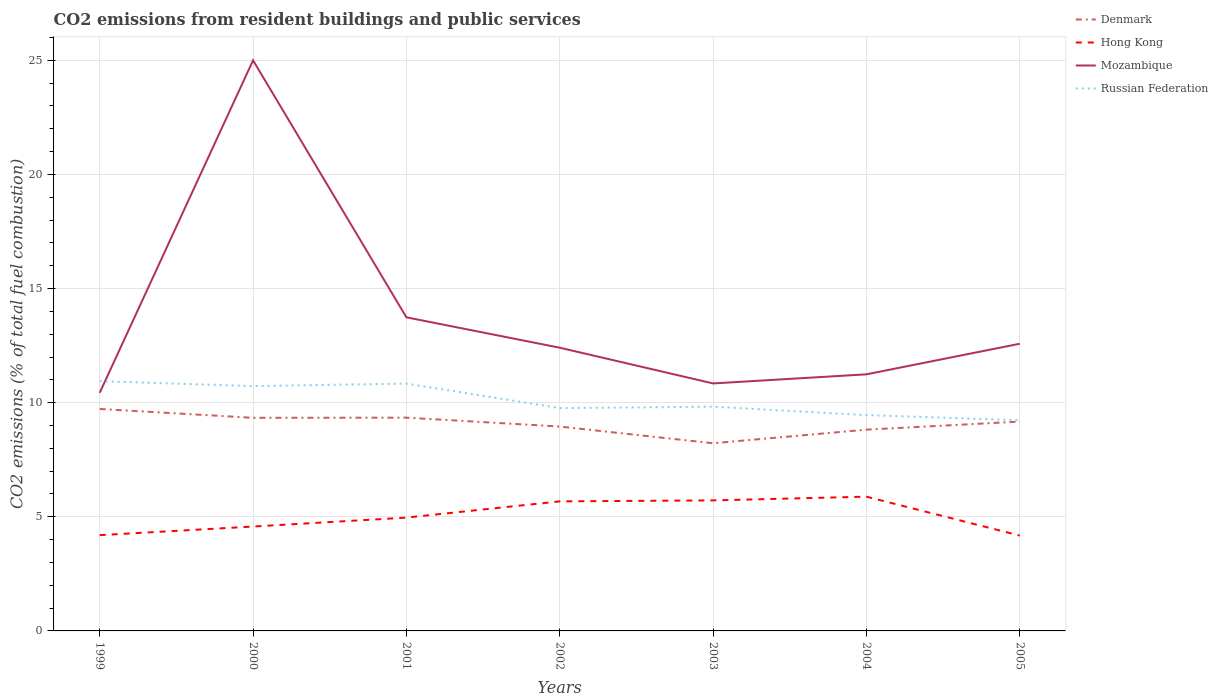How many different coloured lines are there?
Give a very brief answer. 4. Does the line corresponding to Hong Kong intersect with the line corresponding to Russian Federation?
Offer a terse response. No. Across all years, what is the maximum total CO2 emitted in Hong Kong?
Ensure brevity in your answer.  4.18. What is the total total CO2 emitted in Hong Kong in the graph?
Offer a very short reply. 0.02. What is the difference between the highest and the second highest total CO2 emitted in Mozambique?
Offer a very short reply. 14.57. How many lines are there?
Make the answer very short. 4. What is the difference between two consecutive major ticks on the Y-axis?
Ensure brevity in your answer.  5. Are the values on the major ticks of Y-axis written in scientific E-notation?
Your answer should be very brief. No. Does the graph contain any zero values?
Offer a terse response. No. Does the graph contain grids?
Your response must be concise. Yes. How are the legend labels stacked?
Make the answer very short. Vertical. What is the title of the graph?
Your answer should be compact. CO2 emissions from resident buildings and public services. Does "South Asia" appear as one of the legend labels in the graph?
Make the answer very short. No. What is the label or title of the Y-axis?
Ensure brevity in your answer.  CO2 emissions (% of total fuel combustion). What is the CO2 emissions (% of total fuel combustion) of Denmark in 1999?
Ensure brevity in your answer.  9.72. What is the CO2 emissions (% of total fuel combustion) of Hong Kong in 1999?
Your answer should be compact. 4.2. What is the CO2 emissions (% of total fuel combustion) in Mozambique in 1999?
Your answer should be compact. 10.43. What is the CO2 emissions (% of total fuel combustion) of Russian Federation in 1999?
Your response must be concise. 10.94. What is the CO2 emissions (% of total fuel combustion) in Denmark in 2000?
Your answer should be very brief. 9.34. What is the CO2 emissions (% of total fuel combustion) of Hong Kong in 2000?
Provide a succinct answer. 4.57. What is the CO2 emissions (% of total fuel combustion) of Russian Federation in 2000?
Provide a short and direct response. 10.73. What is the CO2 emissions (% of total fuel combustion) of Denmark in 2001?
Make the answer very short. 9.34. What is the CO2 emissions (% of total fuel combustion) of Hong Kong in 2001?
Offer a terse response. 4.96. What is the CO2 emissions (% of total fuel combustion) of Mozambique in 2001?
Provide a succinct answer. 13.74. What is the CO2 emissions (% of total fuel combustion) in Russian Federation in 2001?
Offer a terse response. 10.84. What is the CO2 emissions (% of total fuel combustion) of Denmark in 2002?
Offer a very short reply. 8.95. What is the CO2 emissions (% of total fuel combustion) in Hong Kong in 2002?
Your response must be concise. 5.68. What is the CO2 emissions (% of total fuel combustion) of Mozambique in 2002?
Provide a short and direct response. 12.41. What is the CO2 emissions (% of total fuel combustion) of Russian Federation in 2002?
Provide a short and direct response. 9.76. What is the CO2 emissions (% of total fuel combustion) in Denmark in 2003?
Keep it short and to the point. 8.22. What is the CO2 emissions (% of total fuel combustion) in Hong Kong in 2003?
Provide a succinct answer. 5.72. What is the CO2 emissions (% of total fuel combustion) of Mozambique in 2003?
Provide a succinct answer. 10.84. What is the CO2 emissions (% of total fuel combustion) of Russian Federation in 2003?
Your answer should be very brief. 9.83. What is the CO2 emissions (% of total fuel combustion) in Denmark in 2004?
Make the answer very short. 8.82. What is the CO2 emissions (% of total fuel combustion) of Hong Kong in 2004?
Offer a terse response. 5.88. What is the CO2 emissions (% of total fuel combustion) in Mozambique in 2004?
Offer a very short reply. 11.24. What is the CO2 emissions (% of total fuel combustion) in Russian Federation in 2004?
Keep it short and to the point. 9.46. What is the CO2 emissions (% of total fuel combustion) of Denmark in 2005?
Give a very brief answer. 9.17. What is the CO2 emissions (% of total fuel combustion) in Hong Kong in 2005?
Offer a very short reply. 4.18. What is the CO2 emissions (% of total fuel combustion) of Mozambique in 2005?
Give a very brief answer. 12.58. What is the CO2 emissions (% of total fuel combustion) in Russian Federation in 2005?
Provide a succinct answer. 9.23. Across all years, what is the maximum CO2 emissions (% of total fuel combustion) of Denmark?
Ensure brevity in your answer.  9.72. Across all years, what is the maximum CO2 emissions (% of total fuel combustion) of Hong Kong?
Provide a succinct answer. 5.88. Across all years, what is the maximum CO2 emissions (% of total fuel combustion) of Mozambique?
Offer a terse response. 25. Across all years, what is the maximum CO2 emissions (% of total fuel combustion) in Russian Federation?
Provide a short and direct response. 10.94. Across all years, what is the minimum CO2 emissions (% of total fuel combustion) in Denmark?
Offer a terse response. 8.22. Across all years, what is the minimum CO2 emissions (% of total fuel combustion) of Hong Kong?
Ensure brevity in your answer.  4.18. Across all years, what is the minimum CO2 emissions (% of total fuel combustion) of Mozambique?
Offer a very short reply. 10.43. Across all years, what is the minimum CO2 emissions (% of total fuel combustion) of Russian Federation?
Offer a terse response. 9.23. What is the total CO2 emissions (% of total fuel combustion) of Denmark in the graph?
Your answer should be very brief. 63.57. What is the total CO2 emissions (% of total fuel combustion) of Hong Kong in the graph?
Your response must be concise. 35.19. What is the total CO2 emissions (% of total fuel combustion) in Mozambique in the graph?
Provide a succinct answer. 96.25. What is the total CO2 emissions (% of total fuel combustion) of Russian Federation in the graph?
Keep it short and to the point. 70.78. What is the difference between the CO2 emissions (% of total fuel combustion) of Denmark in 1999 and that in 2000?
Make the answer very short. 0.39. What is the difference between the CO2 emissions (% of total fuel combustion) of Hong Kong in 1999 and that in 2000?
Your answer should be compact. -0.38. What is the difference between the CO2 emissions (% of total fuel combustion) in Mozambique in 1999 and that in 2000?
Ensure brevity in your answer.  -14.57. What is the difference between the CO2 emissions (% of total fuel combustion) of Russian Federation in 1999 and that in 2000?
Provide a short and direct response. 0.21. What is the difference between the CO2 emissions (% of total fuel combustion) in Denmark in 1999 and that in 2001?
Your answer should be compact. 0.38. What is the difference between the CO2 emissions (% of total fuel combustion) in Hong Kong in 1999 and that in 2001?
Offer a terse response. -0.77. What is the difference between the CO2 emissions (% of total fuel combustion) in Mozambique in 1999 and that in 2001?
Your answer should be very brief. -3.31. What is the difference between the CO2 emissions (% of total fuel combustion) of Russian Federation in 1999 and that in 2001?
Give a very brief answer. 0.11. What is the difference between the CO2 emissions (% of total fuel combustion) in Denmark in 1999 and that in 2002?
Give a very brief answer. 0.77. What is the difference between the CO2 emissions (% of total fuel combustion) in Hong Kong in 1999 and that in 2002?
Give a very brief answer. -1.48. What is the difference between the CO2 emissions (% of total fuel combustion) of Mozambique in 1999 and that in 2002?
Give a very brief answer. -1.97. What is the difference between the CO2 emissions (% of total fuel combustion) in Russian Federation in 1999 and that in 2002?
Provide a short and direct response. 1.18. What is the difference between the CO2 emissions (% of total fuel combustion) of Denmark in 1999 and that in 2003?
Your response must be concise. 1.5. What is the difference between the CO2 emissions (% of total fuel combustion) of Hong Kong in 1999 and that in 2003?
Keep it short and to the point. -1.52. What is the difference between the CO2 emissions (% of total fuel combustion) of Mozambique in 1999 and that in 2003?
Offer a very short reply. -0.41. What is the difference between the CO2 emissions (% of total fuel combustion) of Russian Federation in 1999 and that in 2003?
Your response must be concise. 1.12. What is the difference between the CO2 emissions (% of total fuel combustion) in Denmark in 1999 and that in 2004?
Offer a very short reply. 0.91. What is the difference between the CO2 emissions (% of total fuel combustion) of Hong Kong in 1999 and that in 2004?
Provide a succinct answer. -1.69. What is the difference between the CO2 emissions (% of total fuel combustion) in Mozambique in 1999 and that in 2004?
Offer a very short reply. -0.81. What is the difference between the CO2 emissions (% of total fuel combustion) of Russian Federation in 1999 and that in 2004?
Give a very brief answer. 1.49. What is the difference between the CO2 emissions (% of total fuel combustion) in Denmark in 1999 and that in 2005?
Give a very brief answer. 0.55. What is the difference between the CO2 emissions (% of total fuel combustion) of Hong Kong in 1999 and that in 2005?
Make the answer very short. 0.02. What is the difference between the CO2 emissions (% of total fuel combustion) of Mozambique in 1999 and that in 2005?
Give a very brief answer. -2.15. What is the difference between the CO2 emissions (% of total fuel combustion) in Russian Federation in 1999 and that in 2005?
Ensure brevity in your answer.  1.71. What is the difference between the CO2 emissions (% of total fuel combustion) of Denmark in 2000 and that in 2001?
Provide a succinct answer. -0.01. What is the difference between the CO2 emissions (% of total fuel combustion) of Hong Kong in 2000 and that in 2001?
Give a very brief answer. -0.39. What is the difference between the CO2 emissions (% of total fuel combustion) of Mozambique in 2000 and that in 2001?
Provide a short and direct response. 11.26. What is the difference between the CO2 emissions (% of total fuel combustion) in Russian Federation in 2000 and that in 2001?
Make the answer very short. -0.11. What is the difference between the CO2 emissions (% of total fuel combustion) in Denmark in 2000 and that in 2002?
Offer a terse response. 0.38. What is the difference between the CO2 emissions (% of total fuel combustion) of Hong Kong in 2000 and that in 2002?
Your response must be concise. -1.1. What is the difference between the CO2 emissions (% of total fuel combustion) in Mozambique in 2000 and that in 2002?
Keep it short and to the point. 12.59. What is the difference between the CO2 emissions (% of total fuel combustion) in Russian Federation in 2000 and that in 2002?
Offer a terse response. 0.96. What is the difference between the CO2 emissions (% of total fuel combustion) of Denmark in 2000 and that in 2003?
Make the answer very short. 1.12. What is the difference between the CO2 emissions (% of total fuel combustion) in Hong Kong in 2000 and that in 2003?
Your answer should be very brief. -1.15. What is the difference between the CO2 emissions (% of total fuel combustion) in Mozambique in 2000 and that in 2003?
Your answer should be compact. 14.16. What is the difference between the CO2 emissions (% of total fuel combustion) of Russian Federation in 2000 and that in 2003?
Give a very brief answer. 0.9. What is the difference between the CO2 emissions (% of total fuel combustion) of Denmark in 2000 and that in 2004?
Give a very brief answer. 0.52. What is the difference between the CO2 emissions (% of total fuel combustion) of Hong Kong in 2000 and that in 2004?
Ensure brevity in your answer.  -1.31. What is the difference between the CO2 emissions (% of total fuel combustion) in Mozambique in 2000 and that in 2004?
Provide a short and direct response. 13.76. What is the difference between the CO2 emissions (% of total fuel combustion) of Russian Federation in 2000 and that in 2004?
Provide a succinct answer. 1.27. What is the difference between the CO2 emissions (% of total fuel combustion) in Denmark in 2000 and that in 2005?
Your response must be concise. 0.17. What is the difference between the CO2 emissions (% of total fuel combustion) in Hong Kong in 2000 and that in 2005?
Your response must be concise. 0.4. What is the difference between the CO2 emissions (% of total fuel combustion) of Mozambique in 2000 and that in 2005?
Offer a terse response. 12.42. What is the difference between the CO2 emissions (% of total fuel combustion) of Russian Federation in 2000 and that in 2005?
Give a very brief answer. 1.49. What is the difference between the CO2 emissions (% of total fuel combustion) in Denmark in 2001 and that in 2002?
Your answer should be very brief. 0.39. What is the difference between the CO2 emissions (% of total fuel combustion) of Hong Kong in 2001 and that in 2002?
Offer a very short reply. -0.71. What is the difference between the CO2 emissions (% of total fuel combustion) in Mozambique in 2001 and that in 2002?
Ensure brevity in your answer.  1.33. What is the difference between the CO2 emissions (% of total fuel combustion) in Russian Federation in 2001 and that in 2002?
Your answer should be very brief. 1.07. What is the difference between the CO2 emissions (% of total fuel combustion) of Denmark in 2001 and that in 2003?
Your answer should be compact. 1.12. What is the difference between the CO2 emissions (% of total fuel combustion) of Hong Kong in 2001 and that in 2003?
Provide a succinct answer. -0.75. What is the difference between the CO2 emissions (% of total fuel combustion) of Mozambique in 2001 and that in 2003?
Ensure brevity in your answer.  2.9. What is the difference between the CO2 emissions (% of total fuel combustion) of Russian Federation in 2001 and that in 2003?
Make the answer very short. 1.01. What is the difference between the CO2 emissions (% of total fuel combustion) in Denmark in 2001 and that in 2004?
Keep it short and to the point. 0.53. What is the difference between the CO2 emissions (% of total fuel combustion) in Hong Kong in 2001 and that in 2004?
Your answer should be compact. -0.92. What is the difference between the CO2 emissions (% of total fuel combustion) of Mozambique in 2001 and that in 2004?
Provide a short and direct response. 2.5. What is the difference between the CO2 emissions (% of total fuel combustion) of Russian Federation in 2001 and that in 2004?
Give a very brief answer. 1.38. What is the difference between the CO2 emissions (% of total fuel combustion) in Denmark in 2001 and that in 2005?
Your answer should be compact. 0.17. What is the difference between the CO2 emissions (% of total fuel combustion) of Hong Kong in 2001 and that in 2005?
Give a very brief answer. 0.79. What is the difference between the CO2 emissions (% of total fuel combustion) of Mozambique in 2001 and that in 2005?
Provide a short and direct response. 1.16. What is the difference between the CO2 emissions (% of total fuel combustion) of Russian Federation in 2001 and that in 2005?
Offer a very short reply. 1.6. What is the difference between the CO2 emissions (% of total fuel combustion) in Denmark in 2002 and that in 2003?
Provide a short and direct response. 0.73. What is the difference between the CO2 emissions (% of total fuel combustion) in Hong Kong in 2002 and that in 2003?
Offer a very short reply. -0.04. What is the difference between the CO2 emissions (% of total fuel combustion) in Mozambique in 2002 and that in 2003?
Your response must be concise. 1.57. What is the difference between the CO2 emissions (% of total fuel combustion) of Russian Federation in 2002 and that in 2003?
Provide a short and direct response. -0.06. What is the difference between the CO2 emissions (% of total fuel combustion) in Denmark in 2002 and that in 2004?
Offer a very short reply. 0.14. What is the difference between the CO2 emissions (% of total fuel combustion) in Hong Kong in 2002 and that in 2004?
Your answer should be compact. -0.21. What is the difference between the CO2 emissions (% of total fuel combustion) of Mozambique in 2002 and that in 2004?
Provide a short and direct response. 1.17. What is the difference between the CO2 emissions (% of total fuel combustion) in Russian Federation in 2002 and that in 2004?
Your answer should be very brief. 0.31. What is the difference between the CO2 emissions (% of total fuel combustion) of Denmark in 2002 and that in 2005?
Make the answer very short. -0.22. What is the difference between the CO2 emissions (% of total fuel combustion) of Hong Kong in 2002 and that in 2005?
Offer a terse response. 1.5. What is the difference between the CO2 emissions (% of total fuel combustion) of Mozambique in 2002 and that in 2005?
Give a very brief answer. -0.17. What is the difference between the CO2 emissions (% of total fuel combustion) of Russian Federation in 2002 and that in 2005?
Provide a succinct answer. 0.53. What is the difference between the CO2 emissions (% of total fuel combustion) in Denmark in 2003 and that in 2004?
Offer a very short reply. -0.6. What is the difference between the CO2 emissions (% of total fuel combustion) of Hong Kong in 2003 and that in 2004?
Keep it short and to the point. -0.16. What is the difference between the CO2 emissions (% of total fuel combustion) of Mozambique in 2003 and that in 2004?
Keep it short and to the point. -0.4. What is the difference between the CO2 emissions (% of total fuel combustion) of Russian Federation in 2003 and that in 2004?
Your answer should be very brief. 0.37. What is the difference between the CO2 emissions (% of total fuel combustion) in Denmark in 2003 and that in 2005?
Keep it short and to the point. -0.95. What is the difference between the CO2 emissions (% of total fuel combustion) of Hong Kong in 2003 and that in 2005?
Your answer should be very brief. 1.54. What is the difference between the CO2 emissions (% of total fuel combustion) in Mozambique in 2003 and that in 2005?
Offer a very short reply. -1.74. What is the difference between the CO2 emissions (% of total fuel combustion) in Russian Federation in 2003 and that in 2005?
Your answer should be very brief. 0.59. What is the difference between the CO2 emissions (% of total fuel combustion) of Denmark in 2004 and that in 2005?
Provide a succinct answer. -0.35. What is the difference between the CO2 emissions (% of total fuel combustion) of Hong Kong in 2004 and that in 2005?
Your answer should be very brief. 1.7. What is the difference between the CO2 emissions (% of total fuel combustion) in Mozambique in 2004 and that in 2005?
Provide a succinct answer. -1.34. What is the difference between the CO2 emissions (% of total fuel combustion) of Russian Federation in 2004 and that in 2005?
Provide a succinct answer. 0.22. What is the difference between the CO2 emissions (% of total fuel combustion) of Denmark in 1999 and the CO2 emissions (% of total fuel combustion) of Hong Kong in 2000?
Offer a very short reply. 5.15. What is the difference between the CO2 emissions (% of total fuel combustion) in Denmark in 1999 and the CO2 emissions (% of total fuel combustion) in Mozambique in 2000?
Your answer should be very brief. -15.28. What is the difference between the CO2 emissions (% of total fuel combustion) in Denmark in 1999 and the CO2 emissions (% of total fuel combustion) in Russian Federation in 2000?
Offer a terse response. -1. What is the difference between the CO2 emissions (% of total fuel combustion) in Hong Kong in 1999 and the CO2 emissions (% of total fuel combustion) in Mozambique in 2000?
Your answer should be very brief. -20.8. What is the difference between the CO2 emissions (% of total fuel combustion) in Hong Kong in 1999 and the CO2 emissions (% of total fuel combustion) in Russian Federation in 2000?
Your answer should be compact. -6.53. What is the difference between the CO2 emissions (% of total fuel combustion) of Mozambique in 1999 and the CO2 emissions (% of total fuel combustion) of Russian Federation in 2000?
Provide a succinct answer. -0.29. What is the difference between the CO2 emissions (% of total fuel combustion) in Denmark in 1999 and the CO2 emissions (% of total fuel combustion) in Hong Kong in 2001?
Keep it short and to the point. 4.76. What is the difference between the CO2 emissions (% of total fuel combustion) of Denmark in 1999 and the CO2 emissions (% of total fuel combustion) of Mozambique in 2001?
Your answer should be very brief. -4.02. What is the difference between the CO2 emissions (% of total fuel combustion) of Denmark in 1999 and the CO2 emissions (% of total fuel combustion) of Russian Federation in 2001?
Your answer should be compact. -1.11. What is the difference between the CO2 emissions (% of total fuel combustion) of Hong Kong in 1999 and the CO2 emissions (% of total fuel combustion) of Mozambique in 2001?
Offer a very short reply. -9.54. What is the difference between the CO2 emissions (% of total fuel combustion) of Hong Kong in 1999 and the CO2 emissions (% of total fuel combustion) of Russian Federation in 2001?
Make the answer very short. -6.64. What is the difference between the CO2 emissions (% of total fuel combustion) of Mozambique in 1999 and the CO2 emissions (% of total fuel combustion) of Russian Federation in 2001?
Offer a very short reply. -0.4. What is the difference between the CO2 emissions (% of total fuel combustion) in Denmark in 1999 and the CO2 emissions (% of total fuel combustion) in Hong Kong in 2002?
Your answer should be very brief. 4.05. What is the difference between the CO2 emissions (% of total fuel combustion) in Denmark in 1999 and the CO2 emissions (% of total fuel combustion) in Mozambique in 2002?
Your answer should be very brief. -2.68. What is the difference between the CO2 emissions (% of total fuel combustion) in Denmark in 1999 and the CO2 emissions (% of total fuel combustion) in Russian Federation in 2002?
Your answer should be compact. -0.04. What is the difference between the CO2 emissions (% of total fuel combustion) in Hong Kong in 1999 and the CO2 emissions (% of total fuel combustion) in Mozambique in 2002?
Ensure brevity in your answer.  -8.21. What is the difference between the CO2 emissions (% of total fuel combustion) of Hong Kong in 1999 and the CO2 emissions (% of total fuel combustion) of Russian Federation in 2002?
Provide a short and direct response. -5.57. What is the difference between the CO2 emissions (% of total fuel combustion) of Mozambique in 1999 and the CO2 emissions (% of total fuel combustion) of Russian Federation in 2002?
Give a very brief answer. 0.67. What is the difference between the CO2 emissions (% of total fuel combustion) in Denmark in 1999 and the CO2 emissions (% of total fuel combustion) in Hong Kong in 2003?
Offer a very short reply. 4. What is the difference between the CO2 emissions (% of total fuel combustion) in Denmark in 1999 and the CO2 emissions (% of total fuel combustion) in Mozambique in 2003?
Offer a terse response. -1.12. What is the difference between the CO2 emissions (% of total fuel combustion) of Denmark in 1999 and the CO2 emissions (% of total fuel combustion) of Russian Federation in 2003?
Offer a terse response. -0.1. What is the difference between the CO2 emissions (% of total fuel combustion) of Hong Kong in 1999 and the CO2 emissions (% of total fuel combustion) of Mozambique in 2003?
Make the answer very short. -6.65. What is the difference between the CO2 emissions (% of total fuel combustion) in Hong Kong in 1999 and the CO2 emissions (% of total fuel combustion) in Russian Federation in 2003?
Keep it short and to the point. -5.63. What is the difference between the CO2 emissions (% of total fuel combustion) of Mozambique in 1999 and the CO2 emissions (% of total fuel combustion) of Russian Federation in 2003?
Provide a short and direct response. 0.61. What is the difference between the CO2 emissions (% of total fuel combustion) in Denmark in 1999 and the CO2 emissions (% of total fuel combustion) in Hong Kong in 2004?
Give a very brief answer. 3.84. What is the difference between the CO2 emissions (% of total fuel combustion) of Denmark in 1999 and the CO2 emissions (% of total fuel combustion) of Mozambique in 2004?
Your answer should be very brief. -1.52. What is the difference between the CO2 emissions (% of total fuel combustion) of Denmark in 1999 and the CO2 emissions (% of total fuel combustion) of Russian Federation in 2004?
Offer a terse response. 0.27. What is the difference between the CO2 emissions (% of total fuel combustion) in Hong Kong in 1999 and the CO2 emissions (% of total fuel combustion) in Mozambique in 2004?
Keep it short and to the point. -7.05. What is the difference between the CO2 emissions (% of total fuel combustion) of Hong Kong in 1999 and the CO2 emissions (% of total fuel combustion) of Russian Federation in 2004?
Your answer should be very brief. -5.26. What is the difference between the CO2 emissions (% of total fuel combustion) of Mozambique in 1999 and the CO2 emissions (% of total fuel combustion) of Russian Federation in 2004?
Offer a very short reply. 0.98. What is the difference between the CO2 emissions (% of total fuel combustion) in Denmark in 1999 and the CO2 emissions (% of total fuel combustion) in Hong Kong in 2005?
Give a very brief answer. 5.55. What is the difference between the CO2 emissions (% of total fuel combustion) of Denmark in 1999 and the CO2 emissions (% of total fuel combustion) of Mozambique in 2005?
Your answer should be compact. -2.86. What is the difference between the CO2 emissions (% of total fuel combustion) in Denmark in 1999 and the CO2 emissions (% of total fuel combustion) in Russian Federation in 2005?
Give a very brief answer. 0.49. What is the difference between the CO2 emissions (% of total fuel combustion) of Hong Kong in 1999 and the CO2 emissions (% of total fuel combustion) of Mozambique in 2005?
Ensure brevity in your answer.  -8.39. What is the difference between the CO2 emissions (% of total fuel combustion) of Hong Kong in 1999 and the CO2 emissions (% of total fuel combustion) of Russian Federation in 2005?
Make the answer very short. -5.04. What is the difference between the CO2 emissions (% of total fuel combustion) of Mozambique in 1999 and the CO2 emissions (% of total fuel combustion) of Russian Federation in 2005?
Offer a terse response. 1.2. What is the difference between the CO2 emissions (% of total fuel combustion) of Denmark in 2000 and the CO2 emissions (% of total fuel combustion) of Hong Kong in 2001?
Provide a succinct answer. 4.37. What is the difference between the CO2 emissions (% of total fuel combustion) of Denmark in 2000 and the CO2 emissions (% of total fuel combustion) of Mozambique in 2001?
Your answer should be compact. -4.4. What is the difference between the CO2 emissions (% of total fuel combustion) of Denmark in 2000 and the CO2 emissions (% of total fuel combustion) of Russian Federation in 2001?
Your answer should be compact. -1.5. What is the difference between the CO2 emissions (% of total fuel combustion) of Hong Kong in 2000 and the CO2 emissions (% of total fuel combustion) of Mozambique in 2001?
Provide a succinct answer. -9.17. What is the difference between the CO2 emissions (% of total fuel combustion) of Hong Kong in 2000 and the CO2 emissions (% of total fuel combustion) of Russian Federation in 2001?
Make the answer very short. -6.26. What is the difference between the CO2 emissions (% of total fuel combustion) of Mozambique in 2000 and the CO2 emissions (% of total fuel combustion) of Russian Federation in 2001?
Keep it short and to the point. 14.16. What is the difference between the CO2 emissions (% of total fuel combustion) in Denmark in 2000 and the CO2 emissions (% of total fuel combustion) in Hong Kong in 2002?
Offer a terse response. 3.66. What is the difference between the CO2 emissions (% of total fuel combustion) of Denmark in 2000 and the CO2 emissions (% of total fuel combustion) of Mozambique in 2002?
Give a very brief answer. -3.07. What is the difference between the CO2 emissions (% of total fuel combustion) in Denmark in 2000 and the CO2 emissions (% of total fuel combustion) in Russian Federation in 2002?
Ensure brevity in your answer.  -0.42. What is the difference between the CO2 emissions (% of total fuel combustion) of Hong Kong in 2000 and the CO2 emissions (% of total fuel combustion) of Mozambique in 2002?
Keep it short and to the point. -7.84. What is the difference between the CO2 emissions (% of total fuel combustion) of Hong Kong in 2000 and the CO2 emissions (% of total fuel combustion) of Russian Federation in 2002?
Ensure brevity in your answer.  -5.19. What is the difference between the CO2 emissions (% of total fuel combustion) in Mozambique in 2000 and the CO2 emissions (% of total fuel combustion) in Russian Federation in 2002?
Give a very brief answer. 15.24. What is the difference between the CO2 emissions (% of total fuel combustion) of Denmark in 2000 and the CO2 emissions (% of total fuel combustion) of Hong Kong in 2003?
Give a very brief answer. 3.62. What is the difference between the CO2 emissions (% of total fuel combustion) of Denmark in 2000 and the CO2 emissions (% of total fuel combustion) of Mozambique in 2003?
Offer a very short reply. -1.51. What is the difference between the CO2 emissions (% of total fuel combustion) in Denmark in 2000 and the CO2 emissions (% of total fuel combustion) in Russian Federation in 2003?
Keep it short and to the point. -0.49. What is the difference between the CO2 emissions (% of total fuel combustion) of Hong Kong in 2000 and the CO2 emissions (% of total fuel combustion) of Mozambique in 2003?
Your response must be concise. -6.27. What is the difference between the CO2 emissions (% of total fuel combustion) of Hong Kong in 2000 and the CO2 emissions (% of total fuel combustion) of Russian Federation in 2003?
Keep it short and to the point. -5.25. What is the difference between the CO2 emissions (% of total fuel combustion) in Mozambique in 2000 and the CO2 emissions (% of total fuel combustion) in Russian Federation in 2003?
Offer a terse response. 15.17. What is the difference between the CO2 emissions (% of total fuel combustion) of Denmark in 2000 and the CO2 emissions (% of total fuel combustion) of Hong Kong in 2004?
Keep it short and to the point. 3.46. What is the difference between the CO2 emissions (% of total fuel combustion) of Denmark in 2000 and the CO2 emissions (% of total fuel combustion) of Mozambique in 2004?
Provide a succinct answer. -1.9. What is the difference between the CO2 emissions (% of total fuel combustion) of Denmark in 2000 and the CO2 emissions (% of total fuel combustion) of Russian Federation in 2004?
Your response must be concise. -0.12. What is the difference between the CO2 emissions (% of total fuel combustion) in Hong Kong in 2000 and the CO2 emissions (% of total fuel combustion) in Mozambique in 2004?
Your answer should be compact. -6.67. What is the difference between the CO2 emissions (% of total fuel combustion) of Hong Kong in 2000 and the CO2 emissions (% of total fuel combustion) of Russian Federation in 2004?
Give a very brief answer. -4.88. What is the difference between the CO2 emissions (% of total fuel combustion) in Mozambique in 2000 and the CO2 emissions (% of total fuel combustion) in Russian Federation in 2004?
Your response must be concise. 15.54. What is the difference between the CO2 emissions (% of total fuel combustion) in Denmark in 2000 and the CO2 emissions (% of total fuel combustion) in Hong Kong in 2005?
Offer a very short reply. 5.16. What is the difference between the CO2 emissions (% of total fuel combustion) of Denmark in 2000 and the CO2 emissions (% of total fuel combustion) of Mozambique in 2005?
Your answer should be very brief. -3.24. What is the difference between the CO2 emissions (% of total fuel combustion) of Denmark in 2000 and the CO2 emissions (% of total fuel combustion) of Russian Federation in 2005?
Provide a short and direct response. 0.11. What is the difference between the CO2 emissions (% of total fuel combustion) in Hong Kong in 2000 and the CO2 emissions (% of total fuel combustion) in Mozambique in 2005?
Provide a short and direct response. -8.01. What is the difference between the CO2 emissions (% of total fuel combustion) in Hong Kong in 2000 and the CO2 emissions (% of total fuel combustion) in Russian Federation in 2005?
Your answer should be compact. -4.66. What is the difference between the CO2 emissions (% of total fuel combustion) in Mozambique in 2000 and the CO2 emissions (% of total fuel combustion) in Russian Federation in 2005?
Give a very brief answer. 15.77. What is the difference between the CO2 emissions (% of total fuel combustion) in Denmark in 2001 and the CO2 emissions (% of total fuel combustion) in Hong Kong in 2002?
Provide a succinct answer. 3.67. What is the difference between the CO2 emissions (% of total fuel combustion) in Denmark in 2001 and the CO2 emissions (% of total fuel combustion) in Mozambique in 2002?
Offer a very short reply. -3.06. What is the difference between the CO2 emissions (% of total fuel combustion) of Denmark in 2001 and the CO2 emissions (% of total fuel combustion) of Russian Federation in 2002?
Keep it short and to the point. -0.42. What is the difference between the CO2 emissions (% of total fuel combustion) in Hong Kong in 2001 and the CO2 emissions (% of total fuel combustion) in Mozambique in 2002?
Ensure brevity in your answer.  -7.44. What is the difference between the CO2 emissions (% of total fuel combustion) in Hong Kong in 2001 and the CO2 emissions (% of total fuel combustion) in Russian Federation in 2002?
Your response must be concise. -4.8. What is the difference between the CO2 emissions (% of total fuel combustion) in Mozambique in 2001 and the CO2 emissions (% of total fuel combustion) in Russian Federation in 2002?
Your answer should be very brief. 3.98. What is the difference between the CO2 emissions (% of total fuel combustion) in Denmark in 2001 and the CO2 emissions (% of total fuel combustion) in Hong Kong in 2003?
Ensure brevity in your answer.  3.63. What is the difference between the CO2 emissions (% of total fuel combustion) of Denmark in 2001 and the CO2 emissions (% of total fuel combustion) of Mozambique in 2003?
Ensure brevity in your answer.  -1.5. What is the difference between the CO2 emissions (% of total fuel combustion) of Denmark in 2001 and the CO2 emissions (% of total fuel combustion) of Russian Federation in 2003?
Give a very brief answer. -0.48. What is the difference between the CO2 emissions (% of total fuel combustion) of Hong Kong in 2001 and the CO2 emissions (% of total fuel combustion) of Mozambique in 2003?
Provide a succinct answer. -5.88. What is the difference between the CO2 emissions (% of total fuel combustion) of Hong Kong in 2001 and the CO2 emissions (% of total fuel combustion) of Russian Federation in 2003?
Offer a terse response. -4.86. What is the difference between the CO2 emissions (% of total fuel combustion) of Mozambique in 2001 and the CO2 emissions (% of total fuel combustion) of Russian Federation in 2003?
Keep it short and to the point. 3.91. What is the difference between the CO2 emissions (% of total fuel combustion) in Denmark in 2001 and the CO2 emissions (% of total fuel combustion) in Hong Kong in 2004?
Your answer should be very brief. 3.46. What is the difference between the CO2 emissions (% of total fuel combustion) of Denmark in 2001 and the CO2 emissions (% of total fuel combustion) of Mozambique in 2004?
Ensure brevity in your answer.  -1.9. What is the difference between the CO2 emissions (% of total fuel combustion) in Denmark in 2001 and the CO2 emissions (% of total fuel combustion) in Russian Federation in 2004?
Give a very brief answer. -0.11. What is the difference between the CO2 emissions (% of total fuel combustion) in Hong Kong in 2001 and the CO2 emissions (% of total fuel combustion) in Mozambique in 2004?
Keep it short and to the point. -6.28. What is the difference between the CO2 emissions (% of total fuel combustion) in Hong Kong in 2001 and the CO2 emissions (% of total fuel combustion) in Russian Federation in 2004?
Provide a short and direct response. -4.49. What is the difference between the CO2 emissions (% of total fuel combustion) in Mozambique in 2001 and the CO2 emissions (% of total fuel combustion) in Russian Federation in 2004?
Your answer should be very brief. 4.29. What is the difference between the CO2 emissions (% of total fuel combustion) of Denmark in 2001 and the CO2 emissions (% of total fuel combustion) of Hong Kong in 2005?
Make the answer very short. 5.17. What is the difference between the CO2 emissions (% of total fuel combustion) of Denmark in 2001 and the CO2 emissions (% of total fuel combustion) of Mozambique in 2005?
Ensure brevity in your answer.  -3.24. What is the difference between the CO2 emissions (% of total fuel combustion) of Denmark in 2001 and the CO2 emissions (% of total fuel combustion) of Russian Federation in 2005?
Offer a very short reply. 0.11. What is the difference between the CO2 emissions (% of total fuel combustion) in Hong Kong in 2001 and the CO2 emissions (% of total fuel combustion) in Mozambique in 2005?
Your answer should be compact. -7.62. What is the difference between the CO2 emissions (% of total fuel combustion) in Hong Kong in 2001 and the CO2 emissions (% of total fuel combustion) in Russian Federation in 2005?
Ensure brevity in your answer.  -4.27. What is the difference between the CO2 emissions (% of total fuel combustion) of Mozambique in 2001 and the CO2 emissions (% of total fuel combustion) of Russian Federation in 2005?
Offer a terse response. 4.51. What is the difference between the CO2 emissions (% of total fuel combustion) in Denmark in 2002 and the CO2 emissions (% of total fuel combustion) in Hong Kong in 2003?
Offer a terse response. 3.24. What is the difference between the CO2 emissions (% of total fuel combustion) in Denmark in 2002 and the CO2 emissions (% of total fuel combustion) in Mozambique in 2003?
Make the answer very short. -1.89. What is the difference between the CO2 emissions (% of total fuel combustion) in Denmark in 2002 and the CO2 emissions (% of total fuel combustion) in Russian Federation in 2003?
Your answer should be very brief. -0.87. What is the difference between the CO2 emissions (% of total fuel combustion) of Hong Kong in 2002 and the CO2 emissions (% of total fuel combustion) of Mozambique in 2003?
Your answer should be compact. -5.17. What is the difference between the CO2 emissions (% of total fuel combustion) of Hong Kong in 2002 and the CO2 emissions (% of total fuel combustion) of Russian Federation in 2003?
Keep it short and to the point. -4.15. What is the difference between the CO2 emissions (% of total fuel combustion) in Mozambique in 2002 and the CO2 emissions (% of total fuel combustion) in Russian Federation in 2003?
Keep it short and to the point. 2.58. What is the difference between the CO2 emissions (% of total fuel combustion) of Denmark in 2002 and the CO2 emissions (% of total fuel combustion) of Hong Kong in 2004?
Provide a short and direct response. 3.07. What is the difference between the CO2 emissions (% of total fuel combustion) of Denmark in 2002 and the CO2 emissions (% of total fuel combustion) of Mozambique in 2004?
Your answer should be very brief. -2.29. What is the difference between the CO2 emissions (% of total fuel combustion) of Denmark in 2002 and the CO2 emissions (% of total fuel combustion) of Russian Federation in 2004?
Give a very brief answer. -0.5. What is the difference between the CO2 emissions (% of total fuel combustion) in Hong Kong in 2002 and the CO2 emissions (% of total fuel combustion) in Mozambique in 2004?
Your answer should be very brief. -5.57. What is the difference between the CO2 emissions (% of total fuel combustion) of Hong Kong in 2002 and the CO2 emissions (% of total fuel combustion) of Russian Federation in 2004?
Give a very brief answer. -3.78. What is the difference between the CO2 emissions (% of total fuel combustion) in Mozambique in 2002 and the CO2 emissions (% of total fuel combustion) in Russian Federation in 2004?
Keep it short and to the point. 2.95. What is the difference between the CO2 emissions (% of total fuel combustion) in Denmark in 2002 and the CO2 emissions (% of total fuel combustion) in Hong Kong in 2005?
Give a very brief answer. 4.78. What is the difference between the CO2 emissions (% of total fuel combustion) in Denmark in 2002 and the CO2 emissions (% of total fuel combustion) in Mozambique in 2005?
Offer a terse response. -3.63. What is the difference between the CO2 emissions (% of total fuel combustion) of Denmark in 2002 and the CO2 emissions (% of total fuel combustion) of Russian Federation in 2005?
Your response must be concise. -0.28. What is the difference between the CO2 emissions (% of total fuel combustion) of Hong Kong in 2002 and the CO2 emissions (% of total fuel combustion) of Mozambique in 2005?
Provide a short and direct response. -6.91. What is the difference between the CO2 emissions (% of total fuel combustion) in Hong Kong in 2002 and the CO2 emissions (% of total fuel combustion) in Russian Federation in 2005?
Your response must be concise. -3.56. What is the difference between the CO2 emissions (% of total fuel combustion) in Mozambique in 2002 and the CO2 emissions (% of total fuel combustion) in Russian Federation in 2005?
Your answer should be very brief. 3.18. What is the difference between the CO2 emissions (% of total fuel combustion) of Denmark in 2003 and the CO2 emissions (% of total fuel combustion) of Hong Kong in 2004?
Ensure brevity in your answer.  2.34. What is the difference between the CO2 emissions (% of total fuel combustion) in Denmark in 2003 and the CO2 emissions (% of total fuel combustion) in Mozambique in 2004?
Offer a very short reply. -3.02. What is the difference between the CO2 emissions (% of total fuel combustion) of Denmark in 2003 and the CO2 emissions (% of total fuel combustion) of Russian Federation in 2004?
Your answer should be very brief. -1.23. What is the difference between the CO2 emissions (% of total fuel combustion) in Hong Kong in 2003 and the CO2 emissions (% of total fuel combustion) in Mozambique in 2004?
Your answer should be very brief. -5.52. What is the difference between the CO2 emissions (% of total fuel combustion) of Hong Kong in 2003 and the CO2 emissions (% of total fuel combustion) of Russian Federation in 2004?
Keep it short and to the point. -3.74. What is the difference between the CO2 emissions (% of total fuel combustion) of Mozambique in 2003 and the CO2 emissions (% of total fuel combustion) of Russian Federation in 2004?
Your answer should be compact. 1.39. What is the difference between the CO2 emissions (% of total fuel combustion) of Denmark in 2003 and the CO2 emissions (% of total fuel combustion) of Hong Kong in 2005?
Keep it short and to the point. 4.04. What is the difference between the CO2 emissions (% of total fuel combustion) of Denmark in 2003 and the CO2 emissions (% of total fuel combustion) of Mozambique in 2005?
Give a very brief answer. -4.36. What is the difference between the CO2 emissions (% of total fuel combustion) in Denmark in 2003 and the CO2 emissions (% of total fuel combustion) in Russian Federation in 2005?
Give a very brief answer. -1.01. What is the difference between the CO2 emissions (% of total fuel combustion) in Hong Kong in 2003 and the CO2 emissions (% of total fuel combustion) in Mozambique in 2005?
Make the answer very short. -6.86. What is the difference between the CO2 emissions (% of total fuel combustion) in Hong Kong in 2003 and the CO2 emissions (% of total fuel combustion) in Russian Federation in 2005?
Your answer should be compact. -3.51. What is the difference between the CO2 emissions (% of total fuel combustion) of Mozambique in 2003 and the CO2 emissions (% of total fuel combustion) of Russian Federation in 2005?
Make the answer very short. 1.61. What is the difference between the CO2 emissions (% of total fuel combustion) of Denmark in 2004 and the CO2 emissions (% of total fuel combustion) of Hong Kong in 2005?
Ensure brevity in your answer.  4.64. What is the difference between the CO2 emissions (% of total fuel combustion) of Denmark in 2004 and the CO2 emissions (% of total fuel combustion) of Mozambique in 2005?
Keep it short and to the point. -3.76. What is the difference between the CO2 emissions (% of total fuel combustion) in Denmark in 2004 and the CO2 emissions (% of total fuel combustion) in Russian Federation in 2005?
Provide a short and direct response. -0.41. What is the difference between the CO2 emissions (% of total fuel combustion) in Hong Kong in 2004 and the CO2 emissions (% of total fuel combustion) in Mozambique in 2005?
Offer a terse response. -6.7. What is the difference between the CO2 emissions (% of total fuel combustion) in Hong Kong in 2004 and the CO2 emissions (% of total fuel combustion) in Russian Federation in 2005?
Give a very brief answer. -3.35. What is the difference between the CO2 emissions (% of total fuel combustion) in Mozambique in 2004 and the CO2 emissions (% of total fuel combustion) in Russian Federation in 2005?
Offer a terse response. 2.01. What is the average CO2 emissions (% of total fuel combustion) of Denmark per year?
Keep it short and to the point. 9.08. What is the average CO2 emissions (% of total fuel combustion) in Hong Kong per year?
Give a very brief answer. 5.03. What is the average CO2 emissions (% of total fuel combustion) of Mozambique per year?
Keep it short and to the point. 13.75. What is the average CO2 emissions (% of total fuel combustion) in Russian Federation per year?
Your answer should be compact. 10.11. In the year 1999, what is the difference between the CO2 emissions (% of total fuel combustion) of Denmark and CO2 emissions (% of total fuel combustion) of Hong Kong?
Make the answer very short. 5.53. In the year 1999, what is the difference between the CO2 emissions (% of total fuel combustion) of Denmark and CO2 emissions (% of total fuel combustion) of Mozambique?
Offer a terse response. -0.71. In the year 1999, what is the difference between the CO2 emissions (% of total fuel combustion) in Denmark and CO2 emissions (% of total fuel combustion) in Russian Federation?
Provide a succinct answer. -1.22. In the year 1999, what is the difference between the CO2 emissions (% of total fuel combustion) in Hong Kong and CO2 emissions (% of total fuel combustion) in Mozambique?
Ensure brevity in your answer.  -6.24. In the year 1999, what is the difference between the CO2 emissions (% of total fuel combustion) in Hong Kong and CO2 emissions (% of total fuel combustion) in Russian Federation?
Ensure brevity in your answer.  -6.75. In the year 1999, what is the difference between the CO2 emissions (% of total fuel combustion) in Mozambique and CO2 emissions (% of total fuel combustion) in Russian Federation?
Your response must be concise. -0.51. In the year 2000, what is the difference between the CO2 emissions (% of total fuel combustion) in Denmark and CO2 emissions (% of total fuel combustion) in Hong Kong?
Give a very brief answer. 4.76. In the year 2000, what is the difference between the CO2 emissions (% of total fuel combustion) of Denmark and CO2 emissions (% of total fuel combustion) of Mozambique?
Keep it short and to the point. -15.66. In the year 2000, what is the difference between the CO2 emissions (% of total fuel combustion) in Denmark and CO2 emissions (% of total fuel combustion) in Russian Federation?
Make the answer very short. -1.39. In the year 2000, what is the difference between the CO2 emissions (% of total fuel combustion) of Hong Kong and CO2 emissions (% of total fuel combustion) of Mozambique?
Offer a terse response. -20.43. In the year 2000, what is the difference between the CO2 emissions (% of total fuel combustion) in Hong Kong and CO2 emissions (% of total fuel combustion) in Russian Federation?
Provide a succinct answer. -6.15. In the year 2000, what is the difference between the CO2 emissions (% of total fuel combustion) of Mozambique and CO2 emissions (% of total fuel combustion) of Russian Federation?
Your answer should be very brief. 14.27. In the year 2001, what is the difference between the CO2 emissions (% of total fuel combustion) of Denmark and CO2 emissions (% of total fuel combustion) of Hong Kong?
Your answer should be compact. 4.38. In the year 2001, what is the difference between the CO2 emissions (% of total fuel combustion) of Denmark and CO2 emissions (% of total fuel combustion) of Mozambique?
Make the answer very short. -4.4. In the year 2001, what is the difference between the CO2 emissions (% of total fuel combustion) of Denmark and CO2 emissions (% of total fuel combustion) of Russian Federation?
Offer a very short reply. -1.49. In the year 2001, what is the difference between the CO2 emissions (% of total fuel combustion) of Hong Kong and CO2 emissions (% of total fuel combustion) of Mozambique?
Your response must be concise. -8.78. In the year 2001, what is the difference between the CO2 emissions (% of total fuel combustion) in Hong Kong and CO2 emissions (% of total fuel combustion) in Russian Federation?
Offer a very short reply. -5.87. In the year 2001, what is the difference between the CO2 emissions (% of total fuel combustion) in Mozambique and CO2 emissions (% of total fuel combustion) in Russian Federation?
Your response must be concise. 2.91. In the year 2002, what is the difference between the CO2 emissions (% of total fuel combustion) of Denmark and CO2 emissions (% of total fuel combustion) of Hong Kong?
Make the answer very short. 3.28. In the year 2002, what is the difference between the CO2 emissions (% of total fuel combustion) in Denmark and CO2 emissions (% of total fuel combustion) in Mozambique?
Provide a succinct answer. -3.45. In the year 2002, what is the difference between the CO2 emissions (% of total fuel combustion) in Denmark and CO2 emissions (% of total fuel combustion) in Russian Federation?
Offer a terse response. -0.81. In the year 2002, what is the difference between the CO2 emissions (% of total fuel combustion) in Hong Kong and CO2 emissions (% of total fuel combustion) in Mozambique?
Your response must be concise. -6.73. In the year 2002, what is the difference between the CO2 emissions (% of total fuel combustion) of Hong Kong and CO2 emissions (% of total fuel combustion) of Russian Federation?
Make the answer very short. -4.09. In the year 2002, what is the difference between the CO2 emissions (% of total fuel combustion) in Mozambique and CO2 emissions (% of total fuel combustion) in Russian Federation?
Provide a short and direct response. 2.65. In the year 2003, what is the difference between the CO2 emissions (% of total fuel combustion) in Denmark and CO2 emissions (% of total fuel combustion) in Hong Kong?
Offer a very short reply. 2.5. In the year 2003, what is the difference between the CO2 emissions (% of total fuel combustion) in Denmark and CO2 emissions (% of total fuel combustion) in Mozambique?
Make the answer very short. -2.62. In the year 2003, what is the difference between the CO2 emissions (% of total fuel combustion) in Denmark and CO2 emissions (% of total fuel combustion) in Russian Federation?
Make the answer very short. -1.6. In the year 2003, what is the difference between the CO2 emissions (% of total fuel combustion) in Hong Kong and CO2 emissions (% of total fuel combustion) in Mozambique?
Your answer should be very brief. -5.12. In the year 2003, what is the difference between the CO2 emissions (% of total fuel combustion) in Hong Kong and CO2 emissions (% of total fuel combustion) in Russian Federation?
Offer a very short reply. -4.11. In the year 2003, what is the difference between the CO2 emissions (% of total fuel combustion) in Mozambique and CO2 emissions (% of total fuel combustion) in Russian Federation?
Ensure brevity in your answer.  1.02. In the year 2004, what is the difference between the CO2 emissions (% of total fuel combustion) in Denmark and CO2 emissions (% of total fuel combustion) in Hong Kong?
Your answer should be compact. 2.94. In the year 2004, what is the difference between the CO2 emissions (% of total fuel combustion) in Denmark and CO2 emissions (% of total fuel combustion) in Mozambique?
Your answer should be very brief. -2.42. In the year 2004, what is the difference between the CO2 emissions (% of total fuel combustion) of Denmark and CO2 emissions (% of total fuel combustion) of Russian Federation?
Keep it short and to the point. -0.64. In the year 2004, what is the difference between the CO2 emissions (% of total fuel combustion) in Hong Kong and CO2 emissions (% of total fuel combustion) in Mozambique?
Provide a succinct answer. -5.36. In the year 2004, what is the difference between the CO2 emissions (% of total fuel combustion) in Hong Kong and CO2 emissions (% of total fuel combustion) in Russian Federation?
Keep it short and to the point. -3.57. In the year 2004, what is the difference between the CO2 emissions (% of total fuel combustion) in Mozambique and CO2 emissions (% of total fuel combustion) in Russian Federation?
Provide a short and direct response. 1.79. In the year 2005, what is the difference between the CO2 emissions (% of total fuel combustion) in Denmark and CO2 emissions (% of total fuel combustion) in Hong Kong?
Offer a terse response. 4.99. In the year 2005, what is the difference between the CO2 emissions (% of total fuel combustion) in Denmark and CO2 emissions (% of total fuel combustion) in Mozambique?
Your response must be concise. -3.41. In the year 2005, what is the difference between the CO2 emissions (% of total fuel combustion) in Denmark and CO2 emissions (% of total fuel combustion) in Russian Federation?
Make the answer very short. -0.06. In the year 2005, what is the difference between the CO2 emissions (% of total fuel combustion) in Hong Kong and CO2 emissions (% of total fuel combustion) in Mozambique?
Make the answer very short. -8.4. In the year 2005, what is the difference between the CO2 emissions (% of total fuel combustion) in Hong Kong and CO2 emissions (% of total fuel combustion) in Russian Federation?
Provide a short and direct response. -5.05. In the year 2005, what is the difference between the CO2 emissions (% of total fuel combustion) of Mozambique and CO2 emissions (% of total fuel combustion) of Russian Federation?
Ensure brevity in your answer.  3.35. What is the ratio of the CO2 emissions (% of total fuel combustion) in Denmark in 1999 to that in 2000?
Ensure brevity in your answer.  1.04. What is the ratio of the CO2 emissions (% of total fuel combustion) in Hong Kong in 1999 to that in 2000?
Give a very brief answer. 0.92. What is the ratio of the CO2 emissions (% of total fuel combustion) of Mozambique in 1999 to that in 2000?
Keep it short and to the point. 0.42. What is the ratio of the CO2 emissions (% of total fuel combustion) of Russian Federation in 1999 to that in 2000?
Provide a succinct answer. 1.02. What is the ratio of the CO2 emissions (% of total fuel combustion) of Denmark in 1999 to that in 2001?
Your response must be concise. 1.04. What is the ratio of the CO2 emissions (% of total fuel combustion) of Hong Kong in 1999 to that in 2001?
Ensure brevity in your answer.  0.85. What is the ratio of the CO2 emissions (% of total fuel combustion) of Mozambique in 1999 to that in 2001?
Provide a short and direct response. 0.76. What is the ratio of the CO2 emissions (% of total fuel combustion) of Russian Federation in 1999 to that in 2001?
Provide a short and direct response. 1.01. What is the ratio of the CO2 emissions (% of total fuel combustion) in Denmark in 1999 to that in 2002?
Offer a very short reply. 1.09. What is the ratio of the CO2 emissions (% of total fuel combustion) in Hong Kong in 1999 to that in 2002?
Your response must be concise. 0.74. What is the ratio of the CO2 emissions (% of total fuel combustion) of Mozambique in 1999 to that in 2002?
Ensure brevity in your answer.  0.84. What is the ratio of the CO2 emissions (% of total fuel combustion) of Russian Federation in 1999 to that in 2002?
Provide a succinct answer. 1.12. What is the ratio of the CO2 emissions (% of total fuel combustion) of Denmark in 1999 to that in 2003?
Offer a terse response. 1.18. What is the ratio of the CO2 emissions (% of total fuel combustion) of Hong Kong in 1999 to that in 2003?
Provide a succinct answer. 0.73. What is the ratio of the CO2 emissions (% of total fuel combustion) of Mozambique in 1999 to that in 2003?
Your response must be concise. 0.96. What is the ratio of the CO2 emissions (% of total fuel combustion) in Russian Federation in 1999 to that in 2003?
Keep it short and to the point. 1.11. What is the ratio of the CO2 emissions (% of total fuel combustion) of Denmark in 1999 to that in 2004?
Offer a terse response. 1.1. What is the ratio of the CO2 emissions (% of total fuel combustion) of Hong Kong in 1999 to that in 2004?
Your answer should be compact. 0.71. What is the ratio of the CO2 emissions (% of total fuel combustion) of Mozambique in 1999 to that in 2004?
Offer a very short reply. 0.93. What is the ratio of the CO2 emissions (% of total fuel combustion) of Russian Federation in 1999 to that in 2004?
Offer a very short reply. 1.16. What is the ratio of the CO2 emissions (% of total fuel combustion) in Denmark in 1999 to that in 2005?
Give a very brief answer. 1.06. What is the ratio of the CO2 emissions (% of total fuel combustion) of Mozambique in 1999 to that in 2005?
Provide a succinct answer. 0.83. What is the ratio of the CO2 emissions (% of total fuel combustion) in Russian Federation in 1999 to that in 2005?
Your answer should be compact. 1.19. What is the ratio of the CO2 emissions (% of total fuel combustion) in Hong Kong in 2000 to that in 2001?
Provide a succinct answer. 0.92. What is the ratio of the CO2 emissions (% of total fuel combustion) of Mozambique in 2000 to that in 2001?
Offer a terse response. 1.82. What is the ratio of the CO2 emissions (% of total fuel combustion) of Russian Federation in 2000 to that in 2001?
Your answer should be very brief. 0.99. What is the ratio of the CO2 emissions (% of total fuel combustion) in Denmark in 2000 to that in 2002?
Ensure brevity in your answer.  1.04. What is the ratio of the CO2 emissions (% of total fuel combustion) in Hong Kong in 2000 to that in 2002?
Offer a very short reply. 0.81. What is the ratio of the CO2 emissions (% of total fuel combustion) in Mozambique in 2000 to that in 2002?
Keep it short and to the point. 2.01. What is the ratio of the CO2 emissions (% of total fuel combustion) of Russian Federation in 2000 to that in 2002?
Ensure brevity in your answer.  1.1. What is the ratio of the CO2 emissions (% of total fuel combustion) of Denmark in 2000 to that in 2003?
Ensure brevity in your answer.  1.14. What is the ratio of the CO2 emissions (% of total fuel combustion) in Hong Kong in 2000 to that in 2003?
Keep it short and to the point. 0.8. What is the ratio of the CO2 emissions (% of total fuel combustion) in Mozambique in 2000 to that in 2003?
Ensure brevity in your answer.  2.31. What is the ratio of the CO2 emissions (% of total fuel combustion) in Russian Federation in 2000 to that in 2003?
Keep it short and to the point. 1.09. What is the ratio of the CO2 emissions (% of total fuel combustion) of Denmark in 2000 to that in 2004?
Keep it short and to the point. 1.06. What is the ratio of the CO2 emissions (% of total fuel combustion) in Hong Kong in 2000 to that in 2004?
Offer a very short reply. 0.78. What is the ratio of the CO2 emissions (% of total fuel combustion) in Mozambique in 2000 to that in 2004?
Provide a succinct answer. 2.22. What is the ratio of the CO2 emissions (% of total fuel combustion) of Russian Federation in 2000 to that in 2004?
Your response must be concise. 1.13. What is the ratio of the CO2 emissions (% of total fuel combustion) in Denmark in 2000 to that in 2005?
Your response must be concise. 1.02. What is the ratio of the CO2 emissions (% of total fuel combustion) in Hong Kong in 2000 to that in 2005?
Your answer should be very brief. 1.09. What is the ratio of the CO2 emissions (% of total fuel combustion) in Mozambique in 2000 to that in 2005?
Your answer should be compact. 1.99. What is the ratio of the CO2 emissions (% of total fuel combustion) of Russian Federation in 2000 to that in 2005?
Provide a short and direct response. 1.16. What is the ratio of the CO2 emissions (% of total fuel combustion) in Denmark in 2001 to that in 2002?
Offer a terse response. 1.04. What is the ratio of the CO2 emissions (% of total fuel combustion) in Hong Kong in 2001 to that in 2002?
Offer a very short reply. 0.87. What is the ratio of the CO2 emissions (% of total fuel combustion) of Mozambique in 2001 to that in 2002?
Provide a short and direct response. 1.11. What is the ratio of the CO2 emissions (% of total fuel combustion) in Russian Federation in 2001 to that in 2002?
Keep it short and to the point. 1.11. What is the ratio of the CO2 emissions (% of total fuel combustion) of Denmark in 2001 to that in 2003?
Offer a terse response. 1.14. What is the ratio of the CO2 emissions (% of total fuel combustion) of Hong Kong in 2001 to that in 2003?
Make the answer very short. 0.87. What is the ratio of the CO2 emissions (% of total fuel combustion) in Mozambique in 2001 to that in 2003?
Give a very brief answer. 1.27. What is the ratio of the CO2 emissions (% of total fuel combustion) of Russian Federation in 2001 to that in 2003?
Make the answer very short. 1.1. What is the ratio of the CO2 emissions (% of total fuel combustion) of Denmark in 2001 to that in 2004?
Your answer should be compact. 1.06. What is the ratio of the CO2 emissions (% of total fuel combustion) in Hong Kong in 2001 to that in 2004?
Ensure brevity in your answer.  0.84. What is the ratio of the CO2 emissions (% of total fuel combustion) in Mozambique in 2001 to that in 2004?
Your answer should be compact. 1.22. What is the ratio of the CO2 emissions (% of total fuel combustion) in Russian Federation in 2001 to that in 2004?
Offer a terse response. 1.15. What is the ratio of the CO2 emissions (% of total fuel combustion) in Denmark in 2001 to that in 2005?
Your answer should be compact. 1.02. What is the ratio of the CO2 emissions (% of total fuel combustion) of Hong Kong in 2001 to that in 2005?
Offer a very short reply. 1.19. What is the ratio of the CO2 emissions (% of total fuel combustion) of Mozambique in 2001 to that in 2005?
Offer a terse response. 1.09. What is the ratio of the CO2 emissions (% of total fuel combustion) in Russian Federation in 2001 to that in 2005?
Offer a very short reply. 1.17. What is the ratio of the CO2 emissions (% of total fuel combustion) of Denmark in 2002 to that in 2003?
Give a very brief answer. 1.09. What is the ratio of the CO2 emissions (% of total fuel combustion) in Mozambique in 2002 to that in 2003?
Your response must be concise. 1.14. What is the ratio of the CO2 emissions (% of total fuel combustion) in Russian Federation in 2002 to that in 2003?
Provide a succinct answer. 0.99. What is the ratio of the CO2 emissions (% of total fuel combustion) of Denmark in 2002 to that in 2004?
Your response must be concise. 1.02. What is the ratio of the CO2 emissions (% of total fuel combustion) of Mozambique in 2002 to that in 2004?
Keep it short and to the point. 1.1. What is the ratio of the CO2 emissions (% of total fuel combustion) in Russian Federation in 2002 to that in 2004?
Offer a terse response. 1.03. What is the ratio of the CO2 emissions (% of total fuel combustion) in Denmark in 2002 to that in 2005?
Make the answer very short. 0.98. What is the ratio of the CO2 emissions (% of total fuel combustion) of Hong Kong in 2002 to that in 2005?
Your response must be concise. 1.36. What is the ratio of the CO2 emissions (% of total fuel combustion) in Mozambique in 2002 to that in 2005?
Offer a very short reply. 0.99. What is the ratio of the CO2 emissions (% of total fuel combustion) of Russian Federation in 2002 to that in 2005?
Your answer should be compact. 1.06. What is the ratio of the CO2 emissions (% of total fuel combustion) in Denmark in 2003 to that in 2004?
Your answer should be compact. 0.93. What is the ratio of the CO2 emissions (% of total fuel combustion) in Hong Kong in 2003 to that in 2004?
Provide a short and direct response. 0.97. What is the ratio of the CO2 emissions (% of total fuel combustion) of Mozambique in 2003 to that in 2004?
Keep it short and to the point. 0.96. What is the ratio of the CO2 emissions (% of total fuel combustion) in Russian Federation in 2003 to that in 2004?
Give a very brief answer. 1.04. What is the ratio of the CO2 emissions (% of total fuel combustion) of Denmark in 2003 to that in 2005?
Your response must be concise. 0.9. What is the ratio of the CO2 emissions (% of total fuel combustion) in Hong Kong in 2003 to that in 2005?
Ensure brevity in your answer.  1.37. What is the ratio of the CO2 emissions (% of total fuel combustion) in Mozambique in 2003 to that in 2005?
Provide a short and direct response. 0.86. What is the ratio of the CO2 emissions (% of total fuel combustion) of Russian Federation in 2003 to that in 2005?
Your answer should be very brief. 1.06. What is the ratio of the CO2 emissions (% of total fuel combustion) in Denmark in 2004 to that in 2005?
Your response must be concise. 0.96. What is the ratio of the CO2 emissions (% of total fuel combustion) of Hong Kong in 2004 to that in 2005?
Give a very brief answer. 1.41. What is the ratio of the CO2 emissions (% of total fuel combustion) in Mozambique in 2004 to that in 2005?
Your answer should be compact. 0.89. What is the ratio of the CO2 emissions (% of total fuel combustion) in Russian Federation in 2004 to that in 2005?
Ensure brevity in your answer.  1.02. What is the difference between the highest and the second highest CO2 emissions (% of total fuel combustion) in Denmark?
Provide a succinct answer. 0.38. What is the difference between the highest and the second highest CO2 emissions (% of total fuel combustion) in Hong Kong?
Make the answer very short. 0.16. What is the difference between the highest and the second highest CO2 emissions (% of total fuel combustion) in Mozambique?
Your answer should be compact. 11.26. What is the difference between the highest and the second highest CO2 emissions (% of total fuel combustion) of Russian Federation?
Offer a very short reply. 0.11. What is the difference between the highest and the lowest CO2 emissions (% of total fuel combustion) of Denmark?
Offer a terse response. 1.5. What is the difference between the highest and the lowest CO2 emissions (% of total fuel combustion) of Hong Kong?
Your answer should be compact. 1.7. What is the difference between the highest and the lowest CO2 emissions (% of total fuel combustion) of Mozambique?
Provide a succinct answer. 14.57. What is the difference between the highest and the lowest CO2 emissions (% of total fuel combustion) of Russian Federation?
Offer a very short reply. 1.71. 